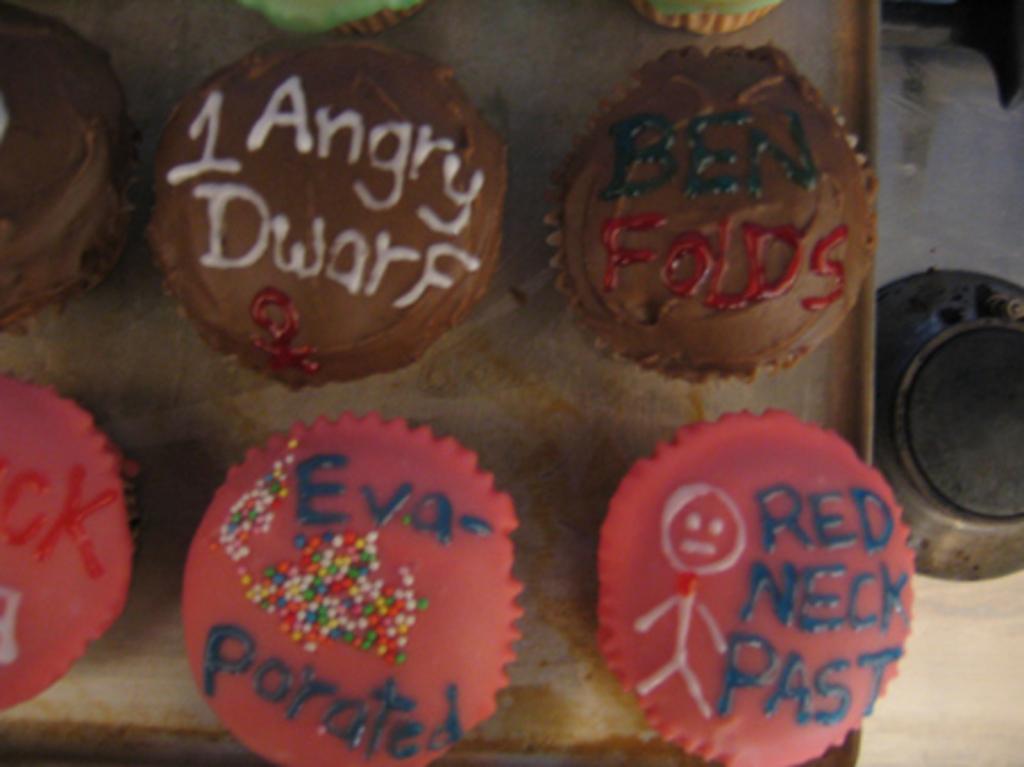In one or two sentences, can you explain what this image depicts? In this image I can see few cupcakes in a tray which is placed on a table. On the right side, I can see a bowl on the floor. 